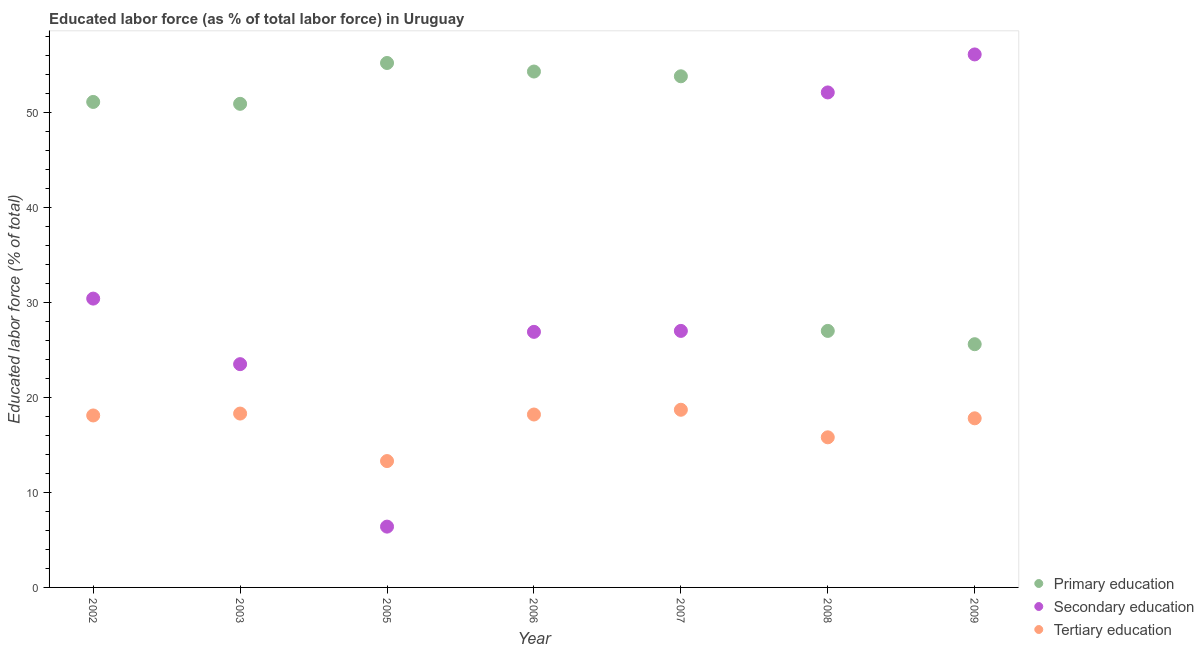How many different coloured dotlines are there?
Provide a short and direct response. 3. What is the percentage of labor force who received primary education in 2009?
Ensure brevity in your answer.  25.6. Across all years, what is the maximum percentage of labor force who received primary education?
Your answer should be compact. 55.2. Across all years, what is the minimum percentage of labor force who received tertiary education?
Your answer should be compact. 13.3. What is the total percentage of labor force who received tertiary education in the graph?
Your answer should be compact. 120.2. What is the difference between the percentage of labor force who received primary education in 2003 and that in 2008?
Offer a very short reply. 23.9. What is the difference between the percentage of labor force who received tertiary education in 2007 and the percentage of labor force who received secondary education in 2002?
Provide a short and direct response. -11.7. What is the average percentage of labor force who received primary education per year?
Provide a succinct answer. 45.41. In the year 2003, what is the difference between the percentage of labor force who received secondary education and percentage of labor force who received tertiary education?
Provide a short and direct response. 5.2. In how many years, is the percentage of labor force who received tertiary education greater than 54 %?
Offer a terse response. 0. What is the ratio of the percentage of labor force who received secondary education in 2007 to that in 2009?
Keep it short and to the point. 0.48. Is the percentage of labor force who received primary education in 2003 less than that in 2006?
Your answer should be very brief. Yes. Is the difference between the percentage of labor force who received secondary education in 2006 and 2009 greater than the difference between the percentage of labor force who received primary education in 2006 and 2009?
Your answer should be compact. No. What is the difference between the highest and the second highest percentage of labor force who received tertiary education?
Your response must be concise. 0.4. What is the difference between the highest and the lowest percentage of labor force who received tertiary education?
Make the answer very short. 5.4. In how many years, is the percentage of labor force who received tertiary education greater than the average percentage of labor force who received tertiary education taken over all years?
Keep it short and to the point. 5. Is it the case that in every year, the sum of the percentage of labor force who received primary education and percentage of labor force who received secondary education is greater than the percentage of labor force who received tertiary education?
Provide a short and direct response. Yes. Is the percentage of labor force who received primary education strictly greater than the percentage of labor force who received secondary education over the years?
Offer a terse response. No. How many dotlines are there?
Offer a very short reply. 3. What is the difference between two consecutive major ticks on the Y-axis?
Offer a very short reply. 10. Does the graph contain any zero values?
Offer a very short reply. No. Where does the legend appear in the graph?
Ensure brevity in your answer.  Bottom right. How many legend labels are there?
Offer a terse response. 3. What is the title of the graph?
Make the answer very short. Educated labor force (as % of total labor force) in Uruguay. What is the label or title of the Y-axis?
Give a very brief answer. Educated labor force (% of total). What is the Educated labor force (% of total) in Primary education in 2002?
Provide a short and direct response. 51.1. What is the Educated labor force (% of total) of Secondary education in 2002?
Your answer should be very brief. 30.4. What is the Educated labor force (% of total) of Tertiary education in 2002?
Give a very brief answer. 18.1. What is the Educated labor force (% of total) in Primary education in 2003?
Keep it short and to the point. 50.9. What is the Educated labor force (% of total) of Tertiary education in 2003?
Make the answer very short. 18.3. What is the Educated labor force (% of total) of Primary education in 2005?
Provide a short and direct response. 55.2. What is the Educated labor force (% of total) of Secondary education in 2005?
Offer a terse response. 6.4. What is the Educated labor force (% of total) in Tertiary education in 2005?
Give a very brief answer. 13.3. What is the Educated labor force (% of total) in Primary education in 2006?
Your answer should be compact. 54.3. What is the Educated labor force (% of total) in Secondary education in 2006?
Make the answer very short. 26.9. What is the Educated labor force (% of total) in Tertiary education in 2006?
Keep it short and to the point. 18.2. What is the Educated labor force (% of total) in Primary education in 2007?
Offer a very short reply. 53.8. What is the Educated labor force (% of total) in Secondary education in 2007?
Make the answer very short. 27. What is the Educated labor force (% of total) of Tertiary education in 2007?
Your answer should be compact. 18.7. What is the Educated labor force (% of total) in Secondary education in 2008?
Your response must be concise. 52.1. What is the Educated labor force (% of total) in Tertiary education in 2008?
Provide a succinct answer. 15.8. What is the Educated labor force (% of total) of Primary education in 2009?
Offer a very short reply. 25.6. What is the Educated labor force (% of total) in Secondary education in 2009?
Provide a succinct answer. 56.1. What is the Educated labor force (% of total) in Tertiary education in 2009?
Offer a terse response. 17.8. Across all years, what is the maximum Educated labor force (% of total) of Primary education?
Give a very brief answer. 55.2. Across all years, what is the maximum Educated labor force (% of total) in Secondary education?
Provide a short and direct response. 56.1. Across all years, what is the maximum Educated labor force (% of total) in Tertiary education?
Ensure brevity in your answer.  18.7. Across all years, what is the minimum Educated labor force (% of total) in Primary education?
Your response must be concise. 25.6. Across all years, what is the minimum Educated labor force (% of total) of Secondary education?
Offer a terse response. 6.4. Across all years, what is the minimum Educated labor force (% of total) in Tertiary education?
Your response must be concise. 13.3. What is the total Educated labor force (% of total) of Primary education in the graph?
Keep it short and to the point. 317.9. What is the total Educated labor force (% of total) in Secondary education in the graph?
Provide a succinct answer. 222.4. What is the total Educated labor force (% of total) in Tertiary education in the graph?
Your response must be concise. 120.2. What is the difference between the Educated labor force (% of total) of Primary education in 2002 and that in 2003?
Make the answer very short. 0.2. What is the difference between the Educated labor force (% of total) of Primary education in 2002 and that in 2005?
Offer a very short reply. -4.1. What is the difference between the Educated labor force (% of total) in Secondary education in 2002 and that in 2005?
Offer a terse response. 24. What is the difference between the Educated labor force (% of total) in Tertiary education in 2002 and that in 2005?
Ensure brevity in your answer.  4.8. What is the difference between the Educated labor force (% of total) in Secondary education in 2002 and that in 2006?
Ensure brevity in your answer.  3.5. What is the difference between the Educated labor force (% of total) of Tertiary education in 2002 and that in 2006?
Make the answer very short. -0.1. What is the difference between the Educated labor force (% of total) in Primary education in 2002 and that in 2007?
Provide a succinct answer. -2.7. What is the difference between the Educated labor force (% of total) in Tertiary education in 2002 and that in 2007?
Your answer should be very brief. -0.6. What is the difference between the Educated labor force (% of total) of Primary education in 2002 and that in 2008?
Make the answer very short. 24.1. What is the difference between the Educated labor force (% of total) in Secondary education in 2002 and that in 2008?
Offer a terse response. -21.7. What is the difference between the Educated labor force (% of total) of Secondary education in 2002 and that in 2009?
Give a very brief answer. -25.7. What is the difference between the Educated labor force (% of total) of Tertiary education in 2002 and that in 2009?
Keep it short and to the point. 0.3. What is the difference between the Educated labor force (% of total) in Primary education in 2003 and that in 2005?
Your response must be concise. -4.3. What is the difference between the Educated labor force (% of total) of Primary education in 2003 and that in 2006?
Keep it short and to the point. -3.4. What is the difference between the Educated labor force (% of total) in Secondary education in 2003 and that in 2006?
Provide a short and direct response. -3.4. What is the difference between the Educated labor force (% of total) of Tertiary education in 2003 and that in 2006?
Your answer should be very brief. 0.1. What is the difference between the Educated labor force (% of total) of Primary education in 2003 and that in 2007?
Your answer should be compact. -2.9. What is the difference between the Educated labor force (% of total) of Primary education in 2003 and that in 2008?
Offer a very short reply. 23.9. What is the difference between the Educated labor force (% of total) of Secondary education in 2003 and that in 2008?
Give a very brief answer. -28.6. What is the difference between the Educated labor force (% of total) of Primary education in 2003 and that in 2009?
Your answer should be compact. 25.3. What is the difference between the Educated labor force (% of total) in Secondary education in 2003 and that in 2009?
Your answer should be compact. -32.6. What is the difference between the Educated labor force (% of total) in Primary education in 2005 and that in 2006?
Keep it short and to the point. 0.9. What is the difference between the Educated labor force (% of total) of Secondary education in 2005 and that in 2006?
Your response must be concise. -20.5. What is the difference between the Educated labor force (% of total) in Secondary education in 2005 and that in 2007?
Give a very brief answer. -20.6. What is the difference between the Educated labor force (% of total) in Tertiary education in 2005 and that in 2007?
Keep it short and to the point. -5.4. What is the difference between the Educated labor force (% of total) of Primary education in 2005 and that in 2008?
Your response must be concise. 28.2. What is the difference between the Educated labor force (% of total) in Secondary education in 2005 and that in 2008?
Offer a very short reply. -45.7. What is the difference between the Educated labor force (% of total) of Primary education in 2005 and that in 2009?
Your answer should be very brief. 29.6. What is the difference between the Educated labor force (% of total) of Secondary education in 2005 and that in 2009?
Keep it short and to the point. -49.7. What is the difference between the Educated labor force (% of total) of Primary education in 2006 and that in 2007?
Provide a succinct answer. 0.5. What is the difference between the Educated labor force (% of total) in Secondary education in 2006 and that in 2007?
Ensure brevity in your answer.  -0.1. What is the difference between the Educated labor force (% of total) in Primary education in 2006 and that in 2008?
Keep it short and to the point. 27.3. What is the difference between the Educated labor force (% of total) in Secondary education in 2006 and that in 2008?
Provide a short and direct response. -25.2. What is the difference between the Educated labor force (% of total) of Primary education in 2006 and that in 2009?
Your response must be concise. 28.7. What is the difference between the Educated labor force (% of total) in Secondary education in 2006 and that in 2009?
Ensure brevity in your answer.  -29.2. What is the difference between the Educated labor force (% of total) of Primary education in 2007 and that in 2008?
Give a very brief answer. 26.8. What is the difference between the Educated labor force (% of total) of Secondary education in 2007 and that in 2008?
Make the answer very short. -25.1. What is the difference between the Educated labor force (% of total) in Tertiary education in 2007 and that in 2008?
Provide a short and direct response. 2.9. What is the difference between the Educated labor force (% of total) in Primary education in 2007 and that in 2009?
Make the answer very short. 28.2. What is the difference between the Educated labor force (% of total) in Secondary education in 2007 and that in 2009?
Offer a terse response. -29.1. What is the difference between the Educated labor force (% of total) of Tertiary education in 2007 and that in 2009?
Give a very brief answer. 0.9. What is the difference between the Educated labor force (% of total) of Primary education in 2008 and that in 2009?
Your answer should be compact. 1.4. What is the difference between the Educated labor force (% of total) in Secondary education in 2008 and that in 2009?
Offer a terse response. -4. What is the difference between the Educated labor force (% of total) of Tertiary education in 2008 and that in 2009?
Ensure brevity in your answer.  -2. What is the difference between the Educated labor force (% of total) in Primary education in 2002 and the Educated labor force (% of total) in Secondary education in 2003?
Give a very brief answer. 27.6. What is the difference between the Educated labor force (% of total) of Primary education in 2002 and the Educated labor force (% of total) of Tertiary education in 2003?
Offer a very short reply. 32.8. What is the difference between the Educated labor force (% of total) of Primary education in 2002 and the Educated labor force (% of total) of Secondary education in 2005?
Your answer should be compact. 44.7. What is the difference between the Educated labor force (% of total) in Primary education in 2002 and the Educated labor force (% of total) in Tertiary education in 2005?
Keep it short and to the point. 37.8. What is the difference between the Educated labor force (% of total) of Primary education in 2002 and the Educated labor force (% of total) of Secondary education in 2006?
Offer a very short reply. 24.2. What is the difference between the Educated labor force (% of total) in Primary education in 2002 and the Educated labor force (% of total) in Tertiary education in 2006?
Make the answer very short. 32.9. What is the difference between the Educated labor force (% of total) in Primary education in 2002 and the Educated labor force (% of total) in Secondary education in 2007?
Offer a very short reply. 24.1. What is the difference between the Educated labor force (% of total) in Primary education in 2002 and the Educated labor force (% of total) in Tertiary education in 2007?
Your answer should be compact. 32.4. What is the difference between the Educated labor force (% of total) of Primary education in 2002 and the Educated labor force (% of total) of Tertiary education in 2008?
Provide a succinct answer. 35.3. What is the difference between the Educated labor force (% of total) of Secondary education in 2002 and the Educated labor force (% of total) of Tertiary education in 2008?
Offer a terse response. 14.6. What is the difference between the Educated labor force (% of total) in Primary education in 2002 and the Educated labor force (% of total) in Tertiary education in 2009?
Keep it short and to the point. 33.3. What is the difference between the Educated labor force (% of total) in Secondary education in 2002 and the Educated labor force (% of total) in Tertiary education in 2009?
Keep it short and to the point. 12.6. What is the difference between the Educated labor force (% of total) in Primary education in 2003 and the Educated labor force (% of total) in Secondary education in 2005?
Your answer should be compact. 44.5. What is the difference between the Educated labor force (% of total) in Primary education in 2003 and the Educated labor force (% of total) in Tertiary education in 2005?
Provide a short and direct response. 37.6. What is the difference between the Educated labor force (% of total) in Primary education in 2003 and the Educated labor force (% of total) in Tertiary education in 2006?
Keep it short and to the point. 32.7. What is the difference between the Educated labor force (% of total) in Secondary education in 2003 and the Educated labor force (% of total) in Tertiary education in 2006?
Give a very brief answer. 5.3. What is the difference between the Educated labor force (% of total) of Primary education in 2003 and the Educated labor force (% of total) of Secondary education in 2007?
Your answer should be very brief. 23.9. What is the difference between the Educated labor force (% of total) of Primary education in 2003 and the Educated labor force (% of total) of Tertiary education in 2007?
Keep it short and to the point. 32.2. What is the difference between the Educated labor force (% of total) in Primary education in 2003 and the Educated labor force (% of total) in Secondary education in 2008?
Give a very brief answer. -1.2. What is the difference between the Educated labor force (% of total) of Primary education in 2003 and the Educated labor force (% of total) of Tertiary education in 2008?
Make the answer very short. 35.1. What is the difference between the Educated labor force (% of total) of Primary education in 2003 and the Educated labor force (% of total) of Tertiary education in 2009?
Offer a terse response. 33.1. What is the difference between the Educated labor force (% of total) of Secondary education in 2003 and the Educated labor force (% of total) of Tertiary education in 2009?
Provide a short and direct response. 5.7. What is the difference between the Educated labor force (% of total) of Primary education in 2005 and the Educated labor force (% of total) of Secondary education in 2006?
Make the answer very short. 28.3. What is the difference between the Educated labor force (% of total) in Primary education in 2005 and the Educated labor force (% of total) in Secondary education in 2007?
Ensure brevity in your answer.  28.2. What is the difference between the Educated labor force (% of total) in Primary education in 2005 and the Educated labor force (% of total) in Tertiary education in 2007?
Give a very brief answer. 36.5. What is the difference between the Educated labor force (% of total) of Secondary education in 2005 and the Educated labor force (% of total) of Tertiary education in 2007?
Your response must be concise. -12.3. What is the difference between the Educated labor force (% of total) of Primary education in 2005 and the Educated labor force (% of total) of Tertiary education in 2008?
Your answer should be compact. 39.4. What is the difference between the Educated labor force (% of total) in Primary education in 2005 and the Educated labor force (% of total) in Secondary education in 2009?
Offer a terse response. -0.9. What is the difference between the Educated labor force (% of total) in Primary education in 2005 and the Educated labor force (% of total) in Tertiary education in 2009?
Make the answer very short. 37.4. What is the difference between the Educated labor force (% of total) of Primary education in 2006 and the Educated labor force (% of total) of Secondary education in 2007?
Provide a succinct answer. 27.3. What is the difference between the Educated labor force (% of total) in Primary education in 2006 and the Educated labor force (% of total) in Tertiary education in 2007?
Provide a short and direct response. 35.6. What is the difference between the Educated labor force (% of total) of Primary education in 2006 and the Educated labor force (% of total) of Secondary education in 2008?
Give a very brief answer. 2.2. What is the difference between the Educated labor force (% of total) in Primary education in 2006 and the Educated labor force (% of total) in Tertiary education in 2008?
Keep it short and to the point. 38.5. What is the difference between the Educated labor force (% of total) of Secondary education in 2006 and the Educated labor force (% of total) of Tertiary education in 2008?
Your response must be concise. 11.1. What is the difference between the Educated labor force (% of total) in Primary education in 2006 and the Educated labor force (% of total) in Secondary education in 2009?
Your answer should be very brief. -1.8. What is the difference between the Educated labor force (% of total) in Primary education in 2006 and the Educated labor force (% of total) in Tertiary education in 2009?
Your answer should be compact. 36.5. What is the difference between the Educated labor force (% of total) of Secondary education in 2006 and the Educated labor force (% of total) of Tertiary education in 2009?
Ensure brevity in your answer.  9.1. What is the difference between the Educated labor force (% of total) of Primary education in 2007 and the Educated labor force (% of total) of Secondary education in 2008?
Offer a terse response. 1.7. What is the difference between the Educated labor force (% of total) of Primary education in 2007 and the Educated labor force (% of total) of Tertiary education in 2008?
Your answer should be very brief. 38. What is the difference between the Educated labor force (% of total) of Primary education in 2008 and the Educated labor force (% of total) of Secondary education in 2009?
Offer a terse response. -29.1. What is the difference between the Educated labor force (% of total) of Secondary education in 2008 and the Educated labor force (% of total) of Tertiary education in 2009?
Offer a very short reply. 34.3. What is the average Educated labor force (% of total) in Primary education per year?
Your answer should be compact. 45.41. What is the average Educated labor force (% of total) of Secondary education per year?
Ensure brevity in your answer.  31.77. What is the average Educated labor force (% of total) in Tertiary education per year?
Offer a very short reply. 17.17. In the year 2002, what is the difference between the Educated labor force (% of total) of Primary education and Educated labor force (% of total) of Secondary education?
Your answer should be very brief. 20.7. In the year 2003, what is the difference between the Educated labor force (% of total) in Primary education and Educated labor force (% of total) in Secondary education?
Provide a succinct answer. 27.4. In the year 2003, what is the difference between the Educated labor force (% of total) of Primary education and Educated labor force (% of total) of Tertiary education?
Offer a very short reply. 32.6. In the year 2005, what is the difference between the Educated labor force (% of total) of Primary education and Educated labor force (% of total) of Secondary education?
Keep it short and to the point. 48.8. In the year 2005, what is the difference between the Educated labor force (% of total) of Primary education and Educated labor force (% of total) of Tertiary education?
Your answer should be compact. 41.9. In the year 2006, what is the difference between the Educated labor force (% of total) of Primary education and Educated labor force (% of total) of Secondary education?
Keep it short and to the point. 27.4. In the year 2006, what is the difference between the Educated labor force (% of total) of Primary education and Educated labor force (% of total) of Tertiary education?
Offer a terse response. 36.1. In the year 2006, what is the difference between the Educated labor force (% of total) in Secondary education and Educated labor force (% of total) in Tertiary education?
Your answer should be compact. 8.7. In the year 2007, what is the difference between the Educated labor force (% of total) of Primary education and Educated labor force (% of total) of Secondary education?
Your answer should be very brief. 26.8. In the year 2007, what is the difference between the Educated labor force (% of total) of Primary education and Educated labor force (% of total) of Tertiary education?
Ensure brevity in your answer.  35.1. In the year 2008, what is the difference between the Educated labor force (% of total) in Primary education and Educated labor force (% of total) in Secondary education?
Provide a short and direct response. -25.1. In the year 2008, what is the difference between the Educated labor force (% of total) in Secondary education and Educated labor force (% of total) in Tertiary education?
Offer a terse response. 36.3. In the year 2009, what is the difference between the Educated labor force (% of total) in Primary education and Educated labor force (% of total) in Secondary education?
Your answer should be compact. -30.5. In the year 2009, what is the difference between the Educated labor force (% of total) of Primary education and Educated labor force (% of total) of Tertiary education?
Offer a terse response. 7.8. In the year 2009, what is the difference between the Educated labor force (% of total) in Secondary education and Educated labor force (% of total) in Tertiary education?
Your answer should be compact. 38.3. What is the ratio of the Educated labor force (% of total) of Primary education in 2002 to that in 2003?
Provide a succinct answer. 1. What is the ratio of the Educated labor force (% of total) in Secondary education in 2002 to that in 2003?
Keep it short and to the point. 1.29. What is the ratio of the Educated labor force (% of total) in Primary education in 2002 to that in 2005?
Offer a terse response. 0.93. What is the ratio of the Educated labor force (% of total) of Secondary education in 2002 to that in 2005?
Keep it short and to the point. 4.75. What is the ratio of the Educated labor force (% of total) in Tertiary education in 2002 to that in 2005?
Your response must be concise. 1.36. What is the ratio of the Educated labor force (% of total) in Primary education in 2002 to that in 2006?
Offer a terse response. 0.94. What is the ratio of the Educated labor force (% of total) of Secondary education in 2002 to that in 2006?
Make the answer very short. 1.13. What is the ratio of the Educated labor force (% of total) of Tertiary education in 2002 to that in 2006?
Provide a short and direct response. 0.99. What is the ratio of the Educated labor force (% of total) of Primary education in 2002 to that in 2007?
Your response must be concise. 0.95. What is the ratio of the Educated labor force (% of total) of Secondary education in 2002 to that in 2007?
Your answer should be very brief. 1.13. What is the ratio of the Educated labor force (% of total) in Tertiary education in 2002 to that in 2007?
Give a very brief answer. 0.97. What is the ratio of the Educated labor force (% of total) in Primary education in 2002 to that in 2008?
Provide a short and direct response. 1.89. What is the ratio of the Educated labor force (% of total) of Secondary education in 2002 to that in 2008?
Your answer should be compact. 0.58. What is the ratio of the Educated labor force (% of total) in Tertiary education in 2002 to that in 2008?
Make the answer very short. 1.15. What is the ratio of the Educated labor force (% of total) of Primary education in 2002 to that in 2009?
Provide a short and direct response. 2. What is the ratio of the Educated labor force (% of total) of Secondary education in 2002 to that in 2009?
Offer a terse response. 0.54. What is the ratio of the Educated labor force (% of total) of Tertiary education in 2002 to that in 2009?
Ensure brevity in your answer.  1.02. What is the ratio of the Educated labor force (% of total) of Primary education in 2003 to that in 2005?
Offer a terse response. 0.92. What is the ratio of the Educated labor force (% of total) of Secondary education in 2003 to that in 2005?
Your answer should be very brief. 3.67. What is the ratio of the Educated labor force (% of total) in Tertiary education in 2003 to that in 2005?
Your response must be concise. 1.38. What is the ratio of the Educated labor force (% of total) in Primary education in 2003 to that in 2006?
Your response must be concise. 0.94. What is the ratio of the Educated labor force (% of total) in Secondary education in 2003 to that in 2006?
Offer a very short reply. 0.87. What is the ratio of the Educated labor force (% of total) in Tertiary education in 2003 to that in 2006?
Make the answer very short. 1.01. What is the ratio of the Educated labor force (% of total) in Primary education in 2003 to that in 2007?
Your response must be concise. 0.95. What is the ratio of the Educated labor force (% of total) in Secondary education in 2003 to that in 2007?
Make the answer very short. 0.87. What is the ratio of the Educated labor force (% of total) in Tertiary education in 2003 to that in 2007?
Ensure brevity in your answer.  0.98. What is the ratio of the Educated labor force (% of total) in Primary education in 2003 to that in 2008?
Provide a short and direct response. 1.89. What is the ratio of the Educated labor force (% of total) of Secondary education in 2003 to that in 2008?
Offer a terse response. 0.45. What is the ratio of the Educated labor force (% of total) in Tertiary education in 2003 to that in 2008?
Make the answer very short. 1.16. What is the ratio of the Educated labor force (% of total) in Primary education in 2003 to that in 2009?
Ensure brevity in your answer.  1.99. What is the ratio of the Educated labor force (% of total) in Secondary education in 2003 to that in 2009?
Your response must be concise. 0.42. What is the ratio of the Educated labor force (% of total) of Tertiary education in 2003 to that in 2009?
Give a very brief answer. 1.03. What is the ratio of the Educated labor force (% of total) in Primary education in 2005 to that in 2006?
Keep it short and to the point. 1.02. What is the ratio of the Educated labor force (% of total) of Secondary education in 2005 to that in 2006?
Make the answer very short. 0.24. What is the ratio of the Educated labor force (% of total) of Tertiary education in 2005 to that in 2006?
Offer a terse response. 0.73. What is the ratio of the Educated labor force (% of total) of Primary education in 2005 to that in 2007?
Make the answer very short. 1.03. What is the ratio of the Educated labor force (% of total) in Secondary education in 2005 to that in 2007?
Keep it short and to the point. 0.24. What is the ratio of the Educated labor force (% of total) in Tertiary education in 2005 to that in 2007?
Provide a short and direct response. 0.71. What is the ratio of the Educated labor force (% of total) in Primary education in 2005 to that in 2008?
Your answer should be very brief. 2.04. What is the ratio of the Educated labor force (% of total) in Secondary education in 2005 to that in 2008?
Your response must be concise. 0.12. What is the ratio of the Educated labor force (% of total) in Tertiary education in 2005 to that in 2008?
Offer a terse response. 0.84. What is the ratio of the Educated labor force (% of total) in Primary education in 2005 to that in 2009?
Give a very brief answer. 2.16. What is the ratio of the Educated labor force (% of total) in Secondary education in 2005 to that in 2009?
Offer a terse response. 0.11. What is the ratio of the Educated labor force (% of total) in Tertiary education in 2005 to that in 2009?
Keep it short and to the point. 0.75. What is the ratio of the Educated labor force (% of total) in Primary education in 2006 to that in 2007?
Your answer should be very brief. 1.01. What is the ratio of the Educated labor force (% of total) of Tertiary education in 2006 to that in 2007?
Make the answer very short. 0.97. What is the ratio of the Educated labor force (% of total) in Primary education in 2006 to that in 2008?
Provide a short and direct response. 2.01. What is the ratio of the Educated labor force (% of total) in Secondary education in 2006 to that in 2008?
Give a very brief answer. 0.52. What is the ratio of the Educated labor force (% of total) of Tertiary education in 2006 to that in 2008?
Make the answer very short. 1.15. What is the ratio of the Educated labor force (% of total) in Primary education in 2006 to that in 2009?
Offer a very short reply. 2.12. What is the ratio of the Educated labor force (% of total) of Secondary education in 2006 to that in 2009?
Offer a very short reply. 0.48. What is the ratio of the Educated labor force (% of total) of Tertiary education in 2006 to that in 2009?
Your answer should be very brief. 1.02. What is the ratio of the Educated labor force (% of total) in Primary education in 2007 to that in 2008?
Make the answer very short. 1.99. What is the ratio of the Educated labor force (% of total) in Secondary education in 2007 to that in 2008?
Give a very brief answer. 0.52. What is the ratio of the Educated labor force (% of total) of Tertiary education in 2007 to that in 2008?
Offer a very short reply. 1.18. What is the ratio of the Educated labor force (% of total) in Primary education in 2007 to that in 2009?
Your response must be concise. 2.1. What is the ratio of the Educated labor force (% of total) in Secondary education in 2007 to that in 2009?
Ensure brevity in your answer.  0.48. What is the ratio of the Educated labor force (% of total) of Tertiary education in 2007 to that in 2009?
Keep it short and to the point. 1.05. What is the ratio of the Educated labor force (% of total) in Primary education in 2008 to that in 2009?
Make the answer very short. 1.05. What is the ratio of the Educated labor force (% of total) of Secondary education in 2008 to that in 2009?
Your answer should be compact. 0.93. What is the ratio of the Educated labor force (% of total) in Tertiary education in 2008 to that in 2009?
Provide a short and direct response. 0.89. What is the difference between the highest and the second highest Educated labor force (% of total) of Tertiary education?
Ensure brevity in your answer.  0.4. What is the difference between the highest and the lowest Educated labor force (% of total) of Primary education?
Make the answer very short. 29.6. What is the difference between the highest and the lowest Educated labor force (% of total) of Secondary education?
Keep it short and to the point. 49.7. What is the difference between the highest and the lowest Educated labor force (% of total) of Tertiary education?
Give a very brief answer. 5.4. 